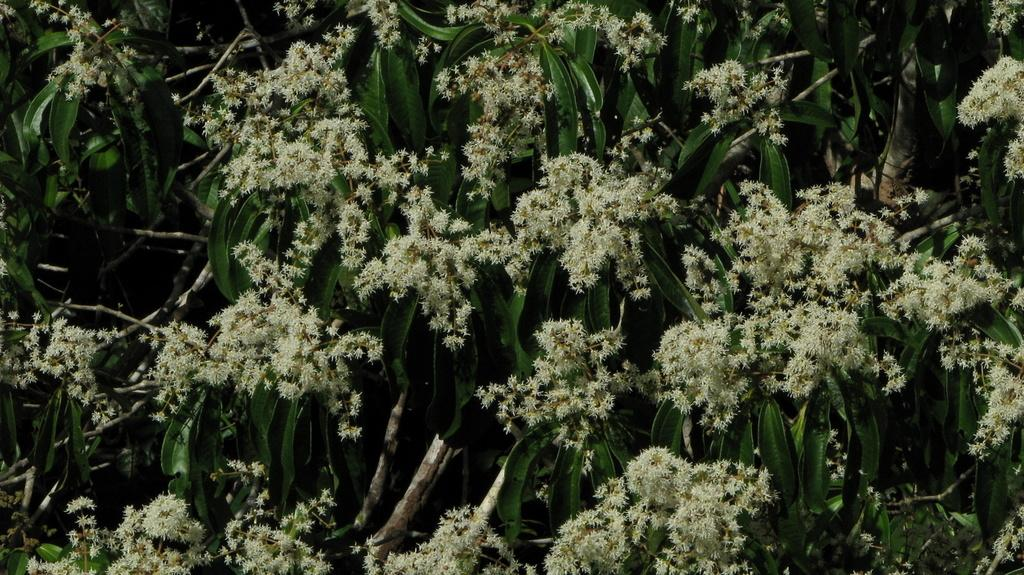What type of vegetation can be seen in the image? There are trees in the image. What is the color of the trees? The trees are green in color. What other flora can be seen in the image? There are flowers in the image. What is the color of the flowers? The flowers are cream in color. How does the arch in the image affect the growth of the trees? There is no arch present in the image; it only features trees and flowers. How does the earthquake in the image impact the color of the flowers? There is no earthquake present in the image, and therefore it cannot impact the color of the flowers. 